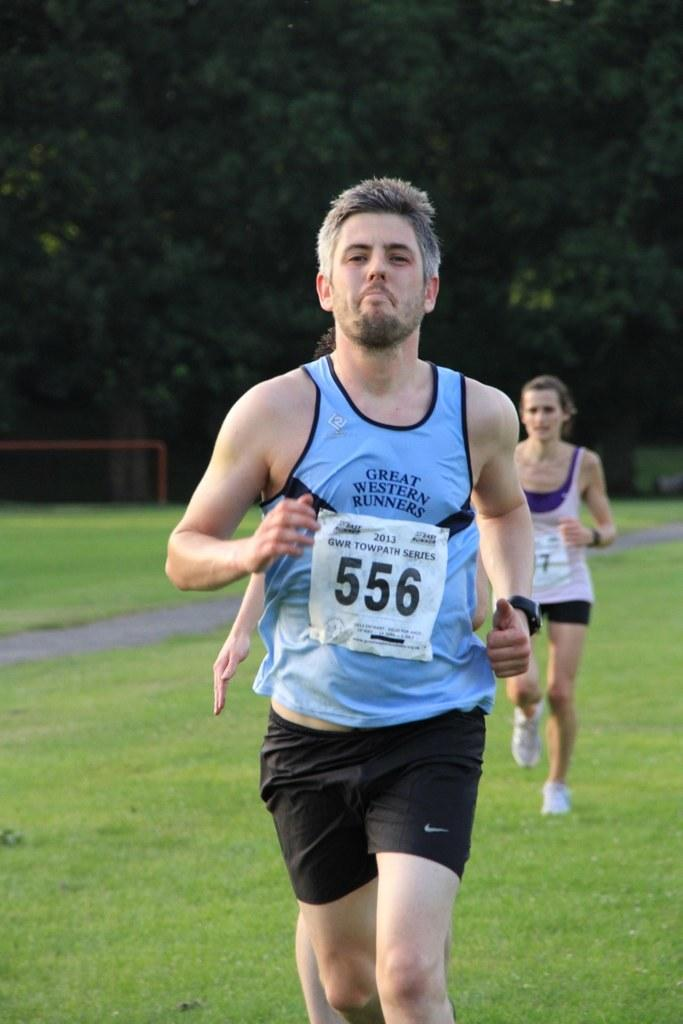<image>
Offer a succinct explanation of the picture presented. Man wearing a label that says 556 running in a race. 